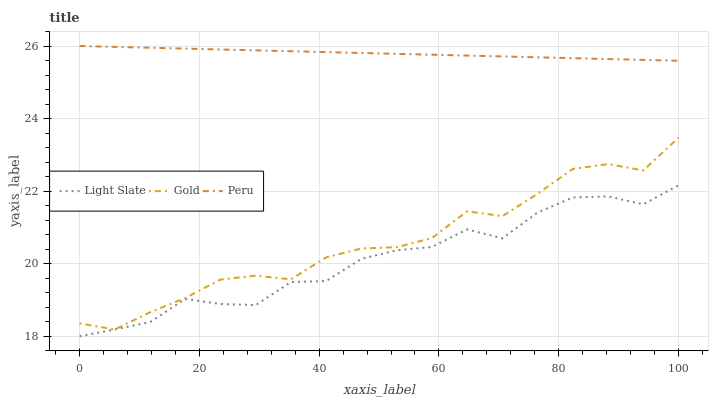Does Light Slate have the minimum area under the curve?
Answer yes or no. Yes. Does Peru have the maximum area under the curve?
Answer yes or no. Yes. Does Gold have the minimum area under the curve?
Answer yes or no. No. Does Gold have the maximum area under the curve?
Answer yes or no. No. Is Peru the smoothest?
Answer yes or no. Yes. Is Light Slate the roughest?
Answer yes or no. Yes. Is Gold the smoothest?
Answer yes or no. No. Is Gold the roughest?
Answer yes or no. No. Does Light Slate have the lowest value?
Answer yes or no. Yes. Does Gold have the lowest value?
Answer yes or no. No. Does Peru have the highest value?
Answer yes or no. Yes. Does Gold have the highest value?
Answer yes or no. No. Is Light Slate less than Peru?
Answer yes or no. Yes. Is Peru greater than Gold?
Answer yes or no. Yes. Does Light Slate intersect Gold?
Answer yes or no. Yes. Is Light Slate less than Gold?
Answer yes or no. No. Is Light Slate greater than Gold?
Answer yes or no. No. Does Light Slate intersect Peru?
Answer yes or no. No. 